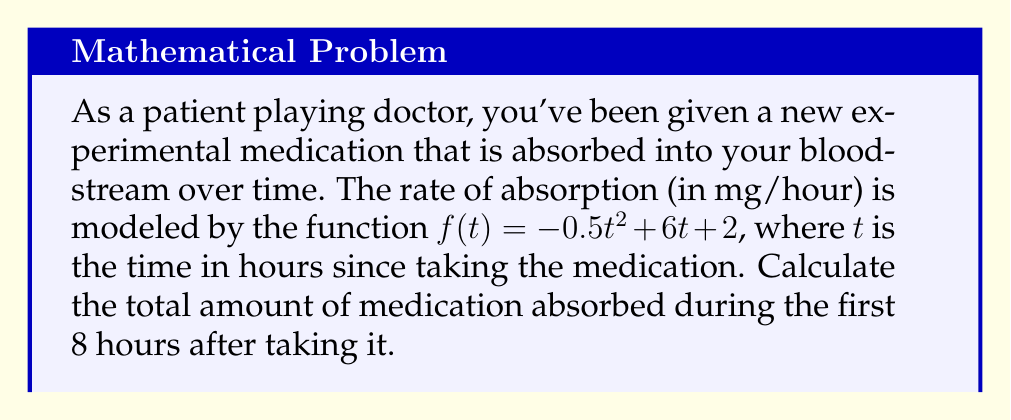Show me your answer to this math problem. To find the total amount of medication absorbed, we need to calculate the area under the curve of the absorption rate function from $t=0$ to $t=8$. This can be done using definite integration.

1) The function describing the absorption rate is:
   $f(t) = -0.5t^2 + 6t + 2$

2) We need to integrate this function from $t=0$ to $t=8$:
   $$\int_0^8 (-0.5t^2 + 6t + 2) dt$$

3) Let's integrate each term:
   $$\int_0^8 -0.5t^2 dt = -\frac{1}{6}t^3 \bigg|_0^8$$
   $$\int_0^8 6t dt = 3t^2 \bigg|_0^8$$
   $$\int_0^8 2 dt = 2t \bigg|_0^8$$

4) Now, let's evaluate each term:
   $$-\frac{1}{6}t^3 \bigg|_0^8 = -\frac{1}{6}(8^3) - (-\frac{1}{6}(0^3)) = -85.33$$
   $$3t^2 \bigg|_0^8 = 3(8^2) - 3(0^2) = 192$$
   $$2t \bigg|_0^8 = 2(8) - 2(0) = 16$$

5) Sum up all the terms:
   $-85.33 + 192 + 16 = 122.67$

Therefore, the total amount of medication absorbed over 8 hours is 122.67 mg.
Answer: 122.67 mg 